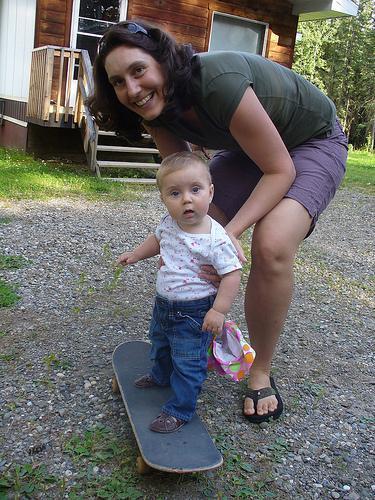How many people are in the picture?
Give a very brief answer. 2. 